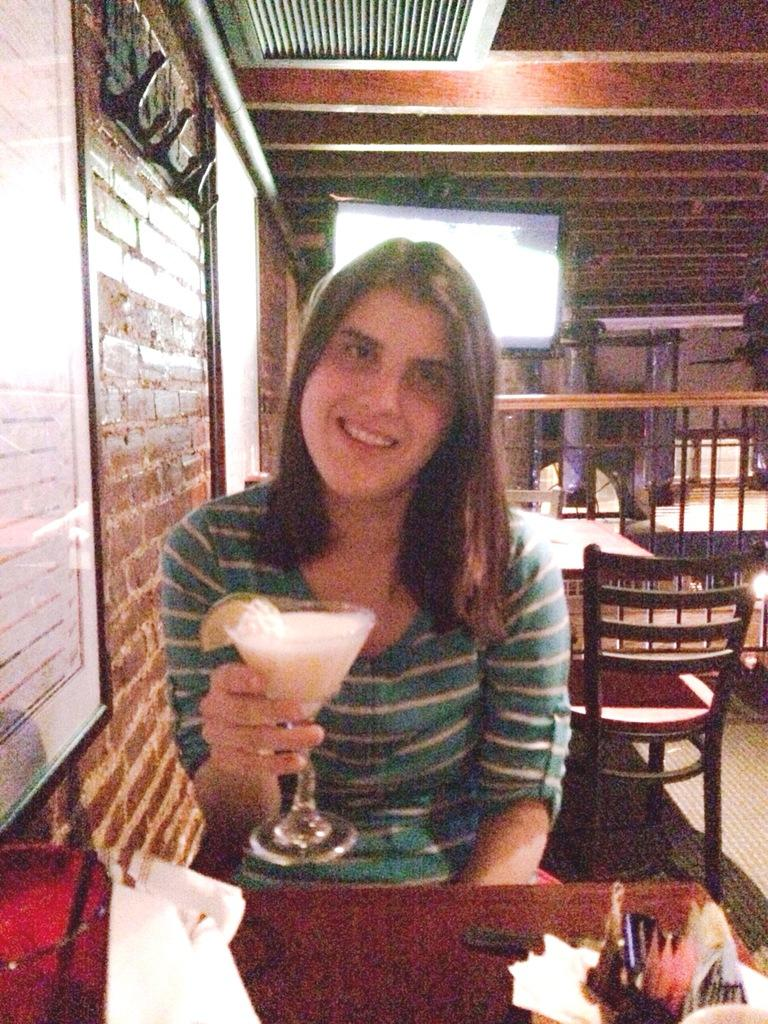What type of establishment is shown in the image? There is a restaurant in the image. Can you describe the woman's position in the image? The woman is sitting on a chair. What is the woman holding in her hand? The woman is holding a glass with a food item in it. What is in front of the woman? There is a table in front of the woman. What type of coast can be seen in the background of the image? There is no coast visible in the image; it is set in a restaurant. 